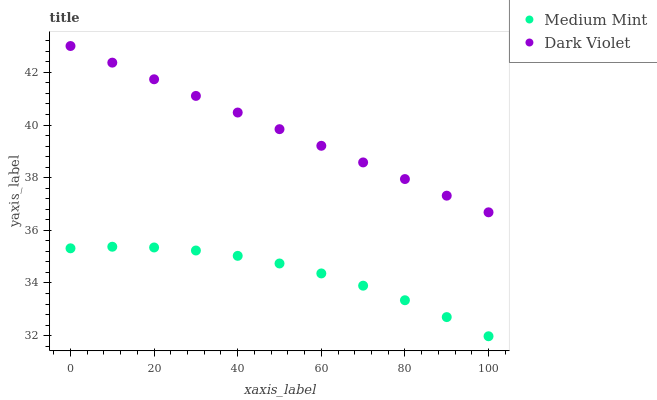Does Medium Mint have the minimum area under the curve?
Answer yes or no. Yes. Does Dark Violet have the maximum area under the curve?
Answer yes or no. Yes. Does Dark Violet have the minimum area under the curve?
Answer yes or no. No. Is Dark Violet the smoothest?
Answer yes or no. Yes. Is Medium Mint the roughest?
Answer yes or no. Yes. Is Dark Violet the roughest?
Answer yes or no. No. Does Medium Mint have the lowest value?
Answer yes or no. Yes. Does Dark Violet have the lowest value?
Answer yes or no. No. Does Dark Violet have the highest value?
Answer yes or no. Yes. Is Medium Mint less than Dark Violet?
Answer yes or no. Yes. Is Dark Violet greater than Medium Mint?
Answer yes or no. Yes. Does Medium Mint intersect Dark Violet?
Answer yes or no. No. 